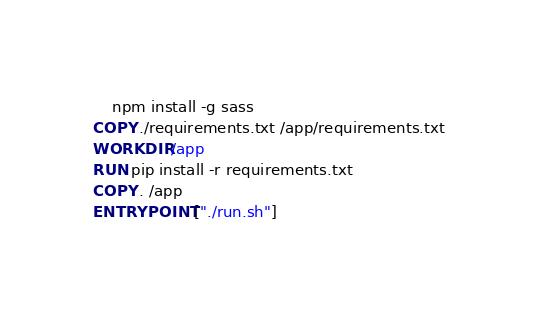<code> <loc_0><loc_0><loc_500><loc_500><_Dockerfile_>    npm install -g sass
COPY ./requirements.txt /app/requirements.txt
WORKDIR /app
RUN pip install -r requirements.txt
COPY . /app
ENTRYPOINT ["./run.sh"]
</code> 